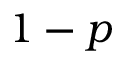Convert formula to latex. <formula><loc_0><loc_0><loc_500><loc_500>1 - p</formula> 